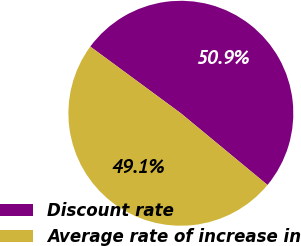Convert chart. <chart><loc_0><loc_0><loc_500><loc_500><pie_chart><fcel>Discount rate<fcel>Average rate of increase in<nl><fcel>50.9%<fcel>49.1%<nl></chart> 